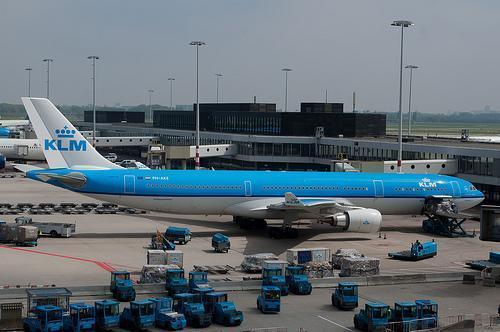How many red planes are there?
Give a very brief answer. 0. 